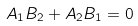Convert formula to latex. <formula><loc_0><loc_0><loc_500><loc_500>A _ { 1 } B _ { 2 } + A _ { 2 } B _ { 1 } = 0</formula> 